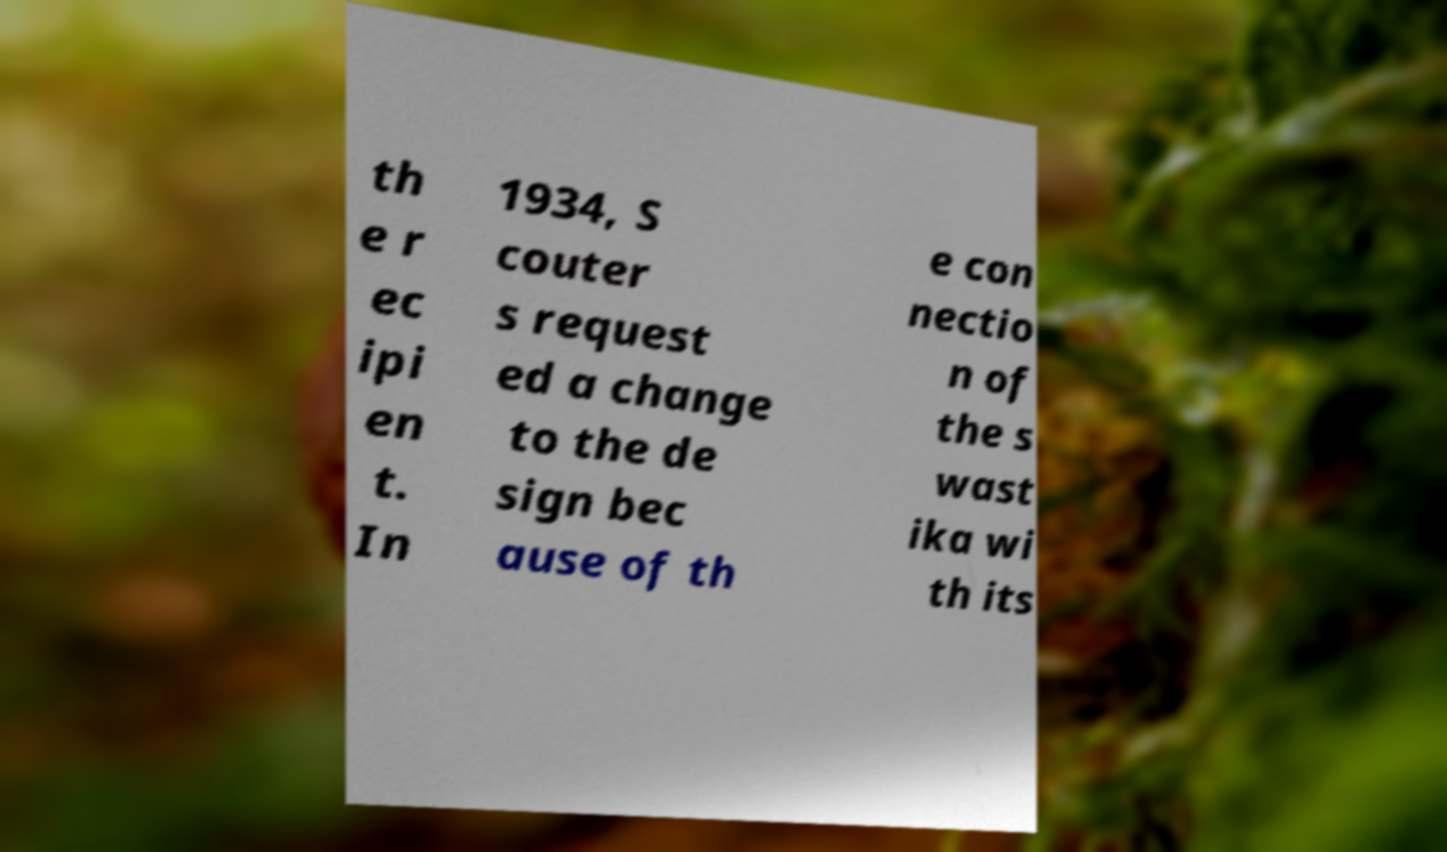Please identify and transcribe the text found in this image. th e r ec ipi en t. In 1934, S couter s request ed a change to the de sign bec ause of th e con nectio n of the s wast ika wi th its 